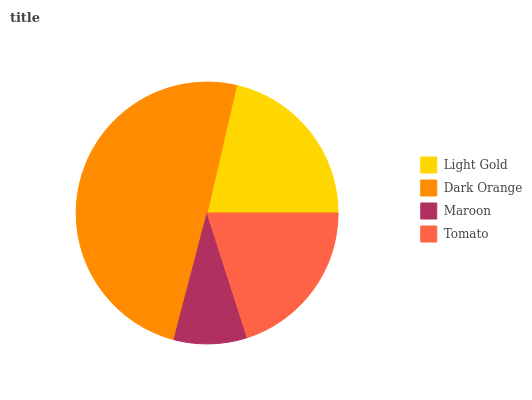Is Maroon the minimum?
Answer yes or no. Yes. Is Dark Orange the maximum?
Answer yes or no. Yes. Is Dark Orange the minimum?
Answer yes or no. No. Is Maroon the maximum?
Answer yes or no. No. Is Dark Orange greater than Maroon?
Answer yes or no. Yes. Is Maroon less than Dark Orange?
Answer yes or no. Yes. Is Maroon greater than Dark Orange?
Answer yes or no. No. Is Dark Orange less than Maroon?
Answer yes or no. No. Is Light Gold the high median?
Answer yes or no. Yes. Is Tomato the low median?
Answer yes or no. Yes. Is Tomato the high median?
Answer yes or no. No. Is Dark Orange the low median?
Answer yes or no. No. 